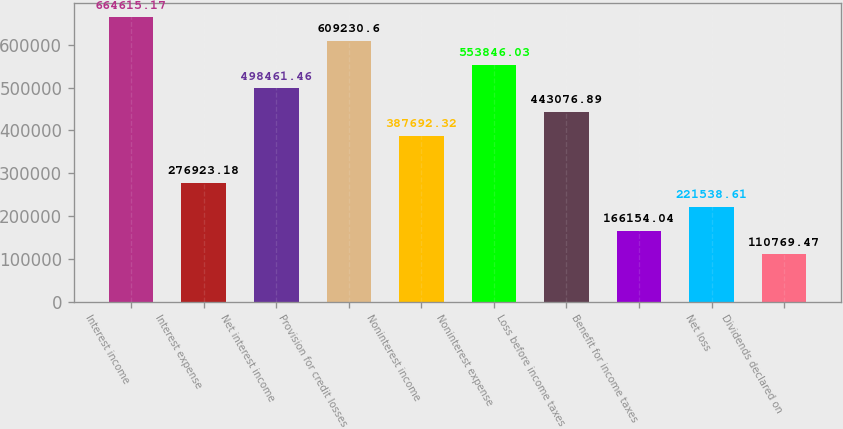<chart> <loc_0><loc_0><loc_500><loc_500><bar_chart><fcel>Interest income<fcel>Interest expense<fcel>Net interest income<fcel>Provision for credit losses<fcel>Noninterest income<fcel>Noninterest expense<fcel>Loss before income taxes<fcel>Benefit for income taxes<fcel>Net loss<fcel>Dividends declared on<nl><fcel>664615<fcel>276923<fcel>498461<fcel>609231<fcel>387692<fcel>553846<fcel>443077<fcel>166154<fcel>221539<fcel>110769<nl></chart> 